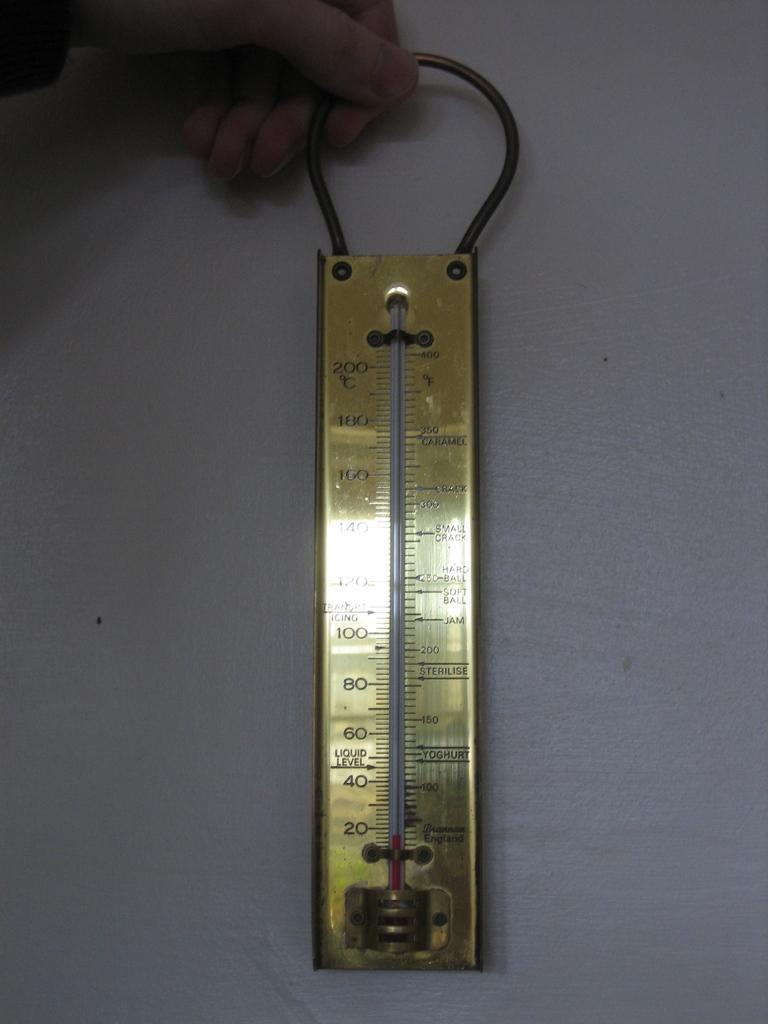What's the lowest measurement?
Offer a very short reply. 20. 